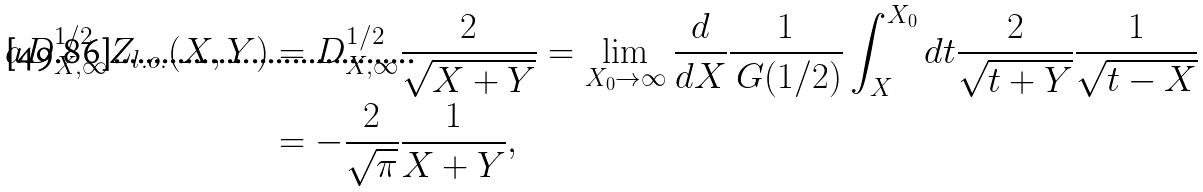Convert formula to latex. <formula><loc_0><loc_0><loc_500><loc_500>a D _ { X , \infty } ^ { 1 / 2 } Z _ { l . o . } ( X , Y ) & = D _ { X , \infty } ^ { 1 / 2 } \frac { 2 } { \sqrt { X + Y } } = \lim _ { X _ { 0 } \to \infty } \frac { d } { d X } \frac { 1 } { \ G ( 1 / 2 ) } \int _ { X } ^ { X _ { 0 } } d t \frac { 2 } { \sqrt { t + Y } } \frac { 1 } { \sqrt { t - X } } \\ & = - \frac { 2 } { \sqrt { \pi } } \frac { 1 } { X + Y } ,</formula> 